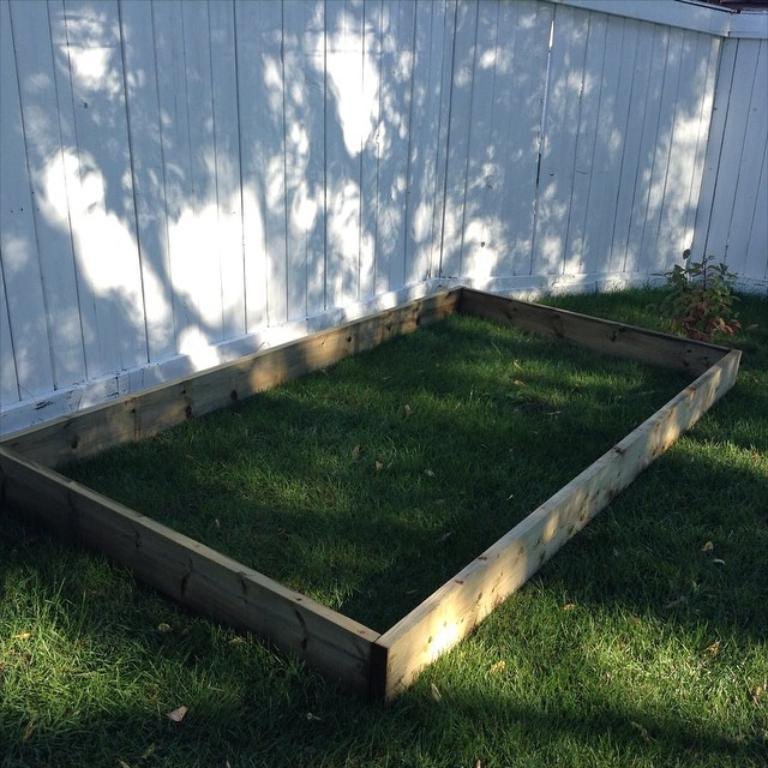What type of material is present in the image? There is wooden material in the image. Where is the wooden material located? The wooden material is on the grass. What other living organism can be seen in the image? There is a plant in the image. What color is the wooden wall in the background of the image? There is a white color wooden wall in the background of the image. What type of reward can be seen hanging from the plant in the image? There is no reward present in the image, nor is there any indication that a reward is hanging from the plant. 